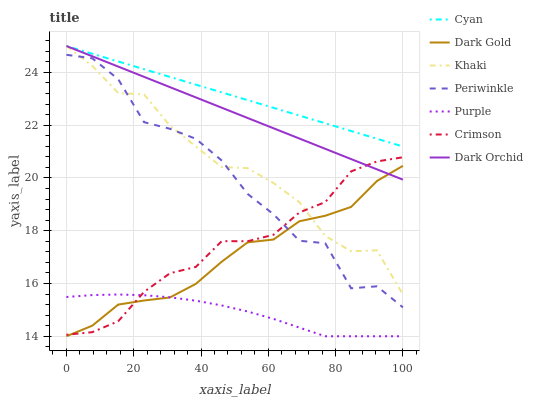Does Purple have the minimum area under the curve?
Answer yes or no. Yes. Does Cyan have the maximum area under the curve?
Answer yes or no. Yes. Does Dark Gold have the minimum area under the curve?
Answer yes or no. No. Does Dark Gold have the maximum area under the curve?
Answer yes or no. No. Is Cyan the smoothest?
Answer yes or no. Yes. Is Periwinkle the roughest?
Answer yes or no. Yes. Is Dark Gold the smoothest?
Answer yes or no. No. Is Dark Gold the roughest?
Answer yes or no. No. Does Dark Orchid have the lowest value?
Answer yes or no. No. Does Cyan have the highest value?
Answer yes or no. Yes. Does Dark Gold have the highest value?
Answer yes or no. No. Is Purple less than Dark Orchid?
Answer yes or no. Yes. Is Dark Orchid greater than Periwinkle?
Answer yes or no. Yes. Does Dark Gold intersect Crimson?
Answer yes or no. Yes. Is Dark Gold less than Crimson?
Answer yes or no. No. Is Dark Gold greater than Crimson?
Answer yes or no. No. Does Purple intersect Dark Orchid?
Answer yes or no. No. 